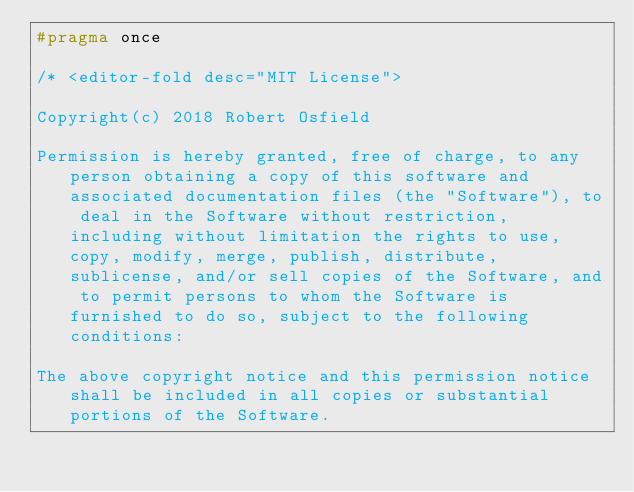<code> <loc_0><loc_0><loc_500><loc_500><_C_>#pragma once

/* <editor-fold desc="MIT License">

Copyright(c) 2018 Robert Osfield

Permission is hereby granted, free of charge, to any person obtaining a copy of this software and associated documentation files (the "Software"), to deal in the Software without restriction, including without limitation the rights to use, copy, modify, merge, publish, distribute, sublicense, and/or sell copies of the Software, and to permit persons to whom the Software is furnished to do so, subject to the following conditions:

The above copyright notice and this permission notice shall be included in all copies or substantial portions of the Software.
</code> 